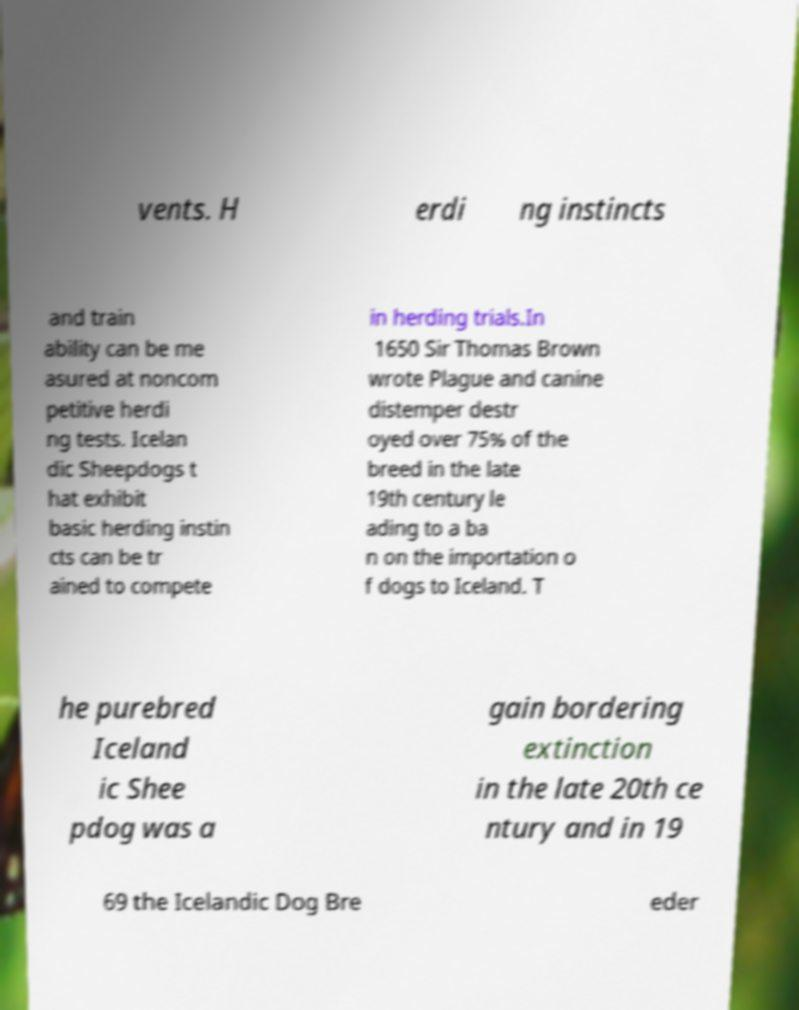Please identify and transcribe the text found in this image. vents. H erdi ng instincts and train ability can be me asured at noncom petitive herdi ng tests. Icelan dic Sheepdogs t hat exhibit basic herding instin cts can be tr ained to compete in herding trials.In 1650 Sir Thomas Brown wrote Plague and canine distemper destr oyed over 75% of the breed in the late 19th century le ading to a ba n on the importation o f dogs to Iceland. T he purebred Iceland ic Shee pdog was a gain bordering extinction in the late 20th ce ntury and in 19 69 the Icelandic Dog Bre eder 